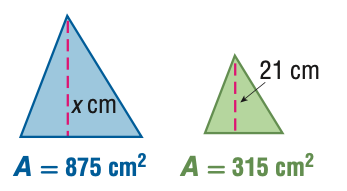Answer the mathemtical geometry problem and directly provide the correct option letter.
Question: For the pair of similar figures, use the given areas to find x.
Choices: A: 7.6 B: 12.6 C: 35 D: 58.3 C 